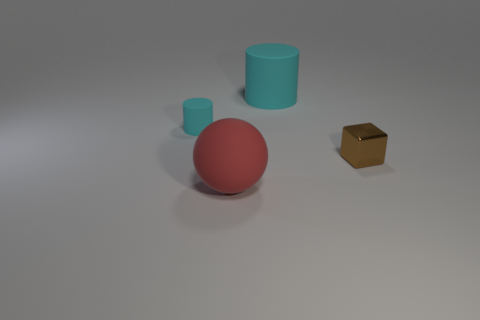What is the size of the other cylinder that is made of the same material as the large cyan cylinder?
Keep it short and to the point. Small. How many other tiny brown metal objects have the same shape as the small brown object?
Offer a very short reply. 0. What number of purple metal cylinders are there?
Offer a very short reply. 0. Do the big object behind the tiny shiny cube and the big red object have the same shape?
Provide a short and direct response. No. Are there the same number of big rubber balls and green shiny cubes?
Your response must be concise. No. There is a object that is the same size as the red sphere; what is it made of?
Offer a very short reply. Rubber. Are there any small red cylinders that have the same material as the ball?
Give a very brief answer. No. Is the shape of the large red object the same as the big matte thing that is behind the tiny shiny cube?
Keep it short and to the point. No. What number of big matte objects are both in front of the metallic object and behind the rubber sphere?
Keep it short and to the point. 0. Are the big cyan object and the cylinder left of the big red rubber sphere made of the same material?
Your answer should be very brief. Yes. 